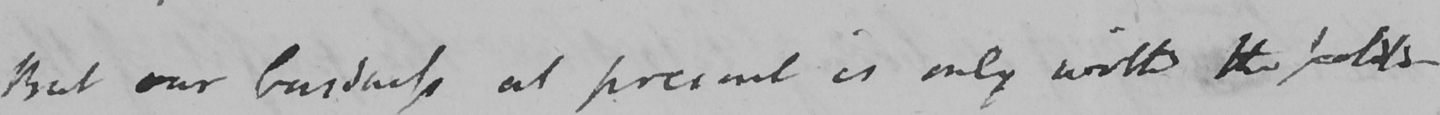Can you tell me what this handwritten text says? But our business at present is only with the politi- 